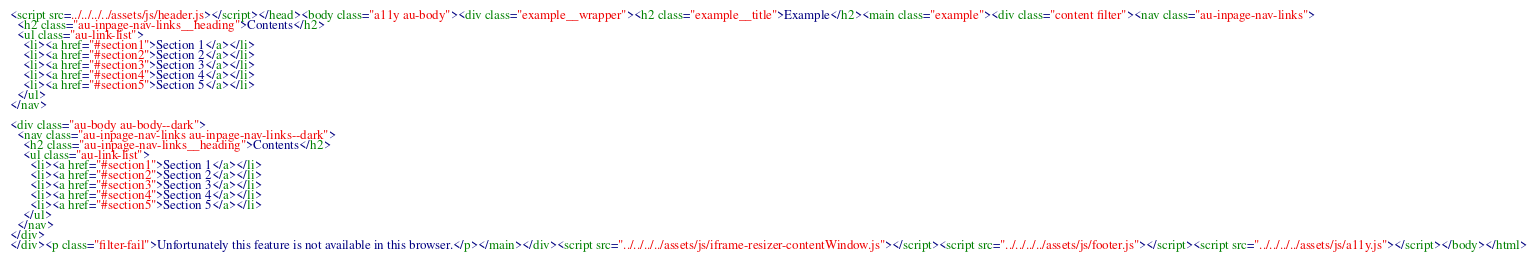<code> <loc_0><loc_0><loc_500><loc_500><_HTML_>
<script src=../../../../assets/js/header.js></script></head><body class="a11y au-body"><div class="example__wrapper"><h2 class="example__title">Example</h2><main class="example"><div class="content filter"><nav class="au-inpage-nav-links">
  <h2 class="au-inpage-nav-links__heading">Contents</h2>
  <ul class="au-link-list">
    <li><a href="#section1">Section 1</a></li>
    <li><a href="#section2">Section 2</a></li>
    <li><a href="#section3">Section 3</a></li>
    <li><a href="#section4">Section 4</a></li>
    <li><a href="#section5">Section 5</a></li>
  </ul>
</nav>

<div class="au-body au-body--dark">
  <nav class="au-inpage-nav-links au-inpage-nav-links--dark">
    <h2 class="au-inpage-nav-links__heading">Contents</h2>
    <ul class="au-link-list">
      <li><a href="#section1">Section 1</a></li>
      <li><a href="#section2">Section 2</a></li>
      <li><a href="#section3">Section 3</a></li>
      <li><a href="#section4">Section 4</a></li>
      <li><a href="#section5">Section 5</a></li>
    </ul>
  </nav>
</div>
</div><p class="filter-fail">Unfortunately this feature is not available in this browser.</p></main></div><script src="../../../../assets/js/iframe-resizer-contentWindow.js"></script><script src="../../../../assets/js/footer.js"></script><script src="../../../../assets/js/a11y.js"></script></body></html></code> 